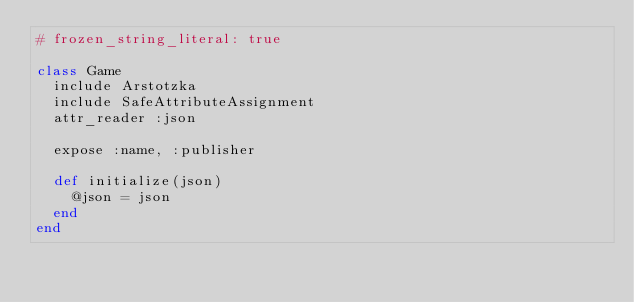<code> <loc_0><loc_0><loc_500><loc_500><_Ruby_># frozen_string_literal: true

class Game
  include Arstotzka
  include SafeAttributeAssignment
  attr_reader :json

  expose :name, :publisher

  def initialize(json)
    @json = json
  end
end
</code> 